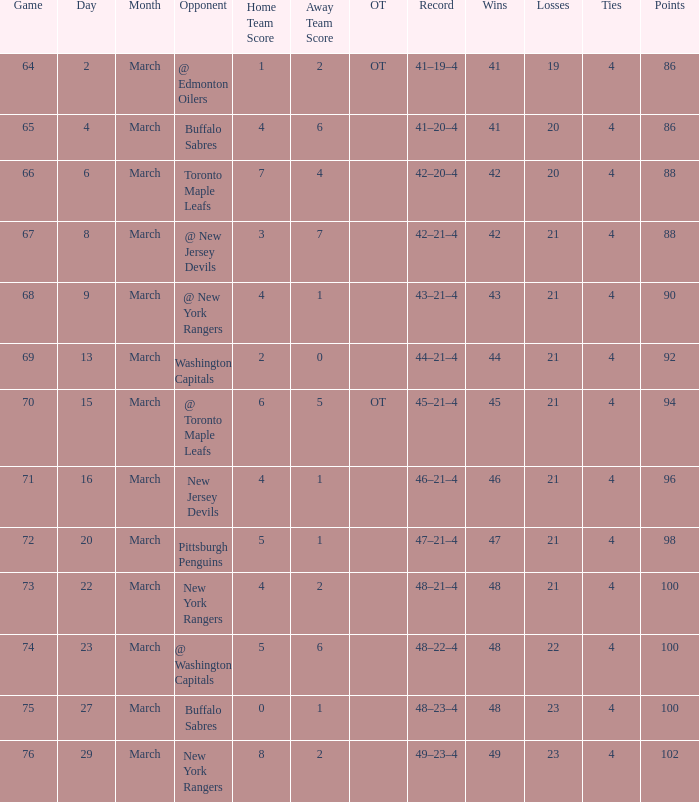Which Opponent has a Record of 45–21–4? @ Toronto Maple Leafs. Parse the full table. {'header': ['Game', 'Day', 'Month', 'Opponent', 'Home Team Score', 'Away Team Score', 'OT', 'Record', 'Wins', 'Losses', 'Ties', 'Points'], 'rows': [['64', '2', 'March', '@ Edmonton Oilers', '1', '2', 'OT', '41–19–4', '41', '19', '4', '86'], ['65', '4', 'March', 'Buffalo Sabres', '4', '6', '', '41–20–4', '41', '20', '4', '86'], ['66', '6', 'March', 'Toronto Maple Leafs', '7', '4', '', '42–20–4', '42', '20', '4', '88'], ['67', '8', 'March', '@ New Jersey Devils', '3', '7', '', '42–21–4', '42', '21', '4', '88'], ['68', '9', 'March', '@ New York Rangers', '4', '1', '', '43–21–4', '43', '21', '4', '90'], ['69', '13', 'March', 'Washington Capitals', '2', '0', '', '44–21–4', '44', '21', '4', '92'], ['70', '15', 'March', '@ Toronto Maple Leafs', '6', '5', 'OT', '45–21–4', '45', '21', '4', '94'], ['71', '16', 'March', 'New Jersey Devils', '4', '1', '', '46–21–4', '46', '21', '4', '96'], ['72', '20', 'March', 'Pittsburgh Penguins', '5', '1', '', '47–21–4', '47', '21', '4', '98'], ['73', '22', 'March', 'New York Rangers', '4', '2', '', '48–21–4', '48', '21', '4', '100'], ['74', '23', 'March', '@ Washington Capitals', '5', '6', '', '48–22–4', '48', '22', '4', '100'], ['75', '27', 'March', 'Buffalo Sabres', '0', '1', '', '48–23–4', '48', '23', '4', '100'], ['76', '29', 'March', 'New York Rangers', '8', '2', '', '49–23–4', '49', '23', '4', '102']]} 